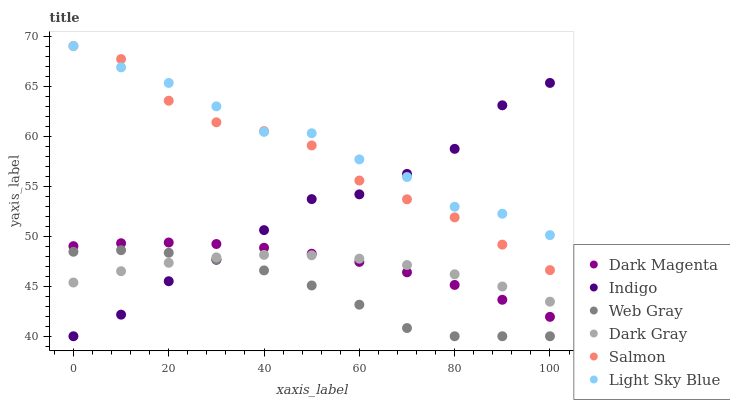Does Web Gray have the minimum area under the curve?
Answer yes or no. Yes. Does Light Sky Blue have the maximum area under the curve?
Answer yes or no. Yes. Does Indigo have the minimum area under the curve?
Answer yes or no. No. Does Indigo have the maximum area under the curve?
Answer yes or no. No. Is Dark Magenta the smoothest?
Answer yes or no. Yes. Is Light Sky Blue the roughest?
Answer yes or no. Yes. Is Indigo the smoothest?
Answer yes or no. No. Is Indigo the roughest?
Answer yes or no. No. Does Web Gray have the lowest value?
Answer yes or no. Yes. Does Dark Magenta have the lowest value?
Answer yes or no. No. Does Light Sky Blue have the highest value?
Answer yes or no. Yes. Does Indigo have the highest value?
Answer yes or no. No. Is Dark Gray less than Salmon?
Answer yes or no. Yes. Is Light Sky Blue greater than Dark Magenta?
Answer yes or no. Yes. Does Dark Gray intersect Dark Magenta?
Answer yes or no. Yes. Is Dark Gray less than Dark Magenta?
Answer yes or no. No. Is Dark Gray greater than Dark Magenta?
Answer yes or no. No. Does Dark Gray intersect Salmon?
Answer yes or no. No. 